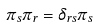<formula> <loc_0><loc_0><loc_500><loc_500>\pi _ { s } \pi _ { r } = \delta _ { r s } \pi _ { s }</formula> 